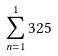<formula> <loc_0><loc_0><loc_500><loc_500>\sum _ { n = 1 } ^ { 1 } 3 2 5</formula> 